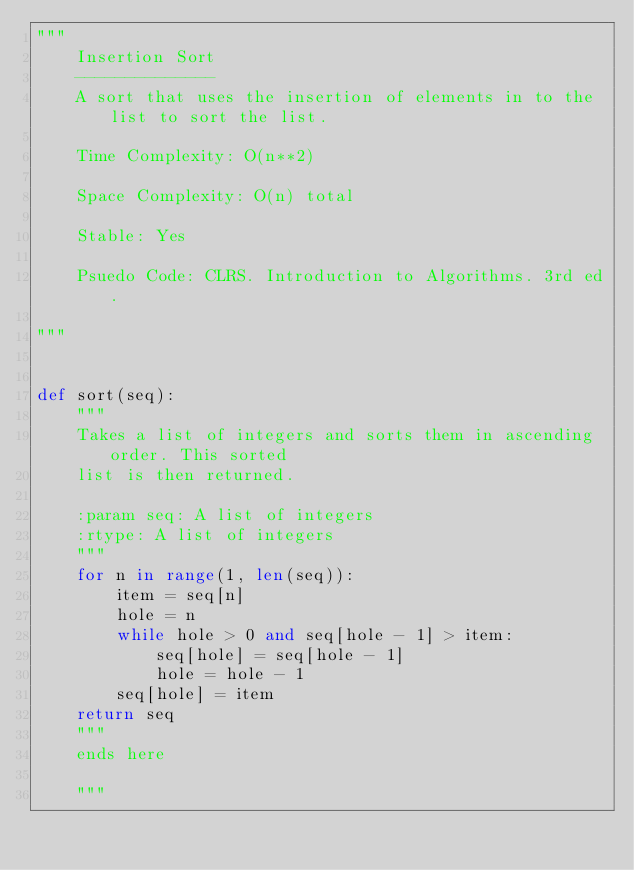Convert code to text. <code><loc_0><loc_0><loc_500><loc_500><_Python_>"""
    Insertion Sort
    --------------
    A sort that uses the insertion of elements in to the list to sort the list.

    Time Complexity: O(n**2)

    Space Complexity: O(n) total

    Stable: Yes

    Psuedo Code: CLRS. Introduction to Algorithms. 3rd ed.

"""


def sort(seq):
    """
    Takes a list of integers and sorts them in ascending order. This sorted
    list is then returned.

    :param seq: A list of integers
    :rtype: A list of integers
    """
    for n in range(1, len(seq)):
        item = seq[n]
        hole = n
        while hole > 0 and seq[hole - 1] > item:
            seq[hole] = seq[hole - 1]
            hole = hole - 1
        seq[hole] = item
    return seq
    """
    ends here 

    """
</code> 